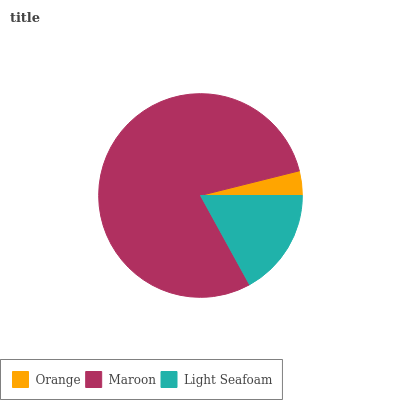Is Orange the minimum?
Answer yes or no. Yes. Is Maroon the maximum?
Answer yes or no. Yes. Is Light Seafoam the minimum?
Answer yes or no. No. Is Light Seafoam the maximum?
Answer yes or no. No. Is Maroon greater than Light Seafoam?
Answer yes or no. Yes. Is Light Seafoam less than Maroon?
Answer yes or no. Yes. Is Light Seafoam greater than Maroon?
Answer yes or no. No. Is Maroon less than Light Seafoam?
Answer yes or no. No. Is Light Seafoam the high median?
Answer yes or no. Yes. Is Light Seafoam the low median?
Answer yes or no. Yes. Is Orange the high median?
Answer yes or no. No. Is Maroon the low median?
Answer yes or no. No. 